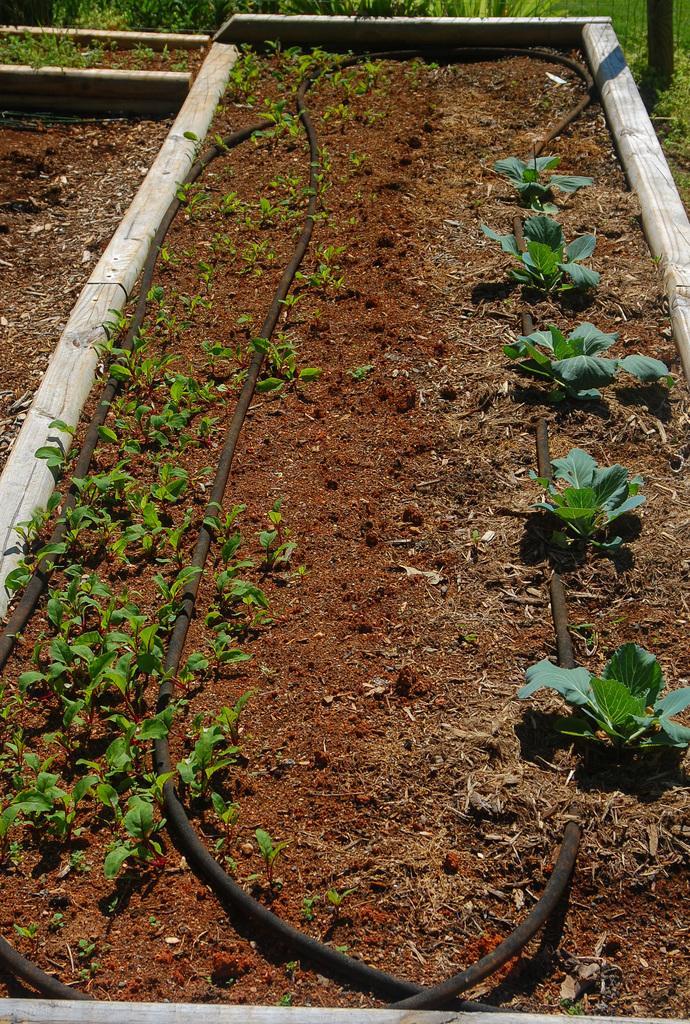In one or two sentences, can you explain what this image depicts? In the image there is a soil surface and in the soil there are some plants. 